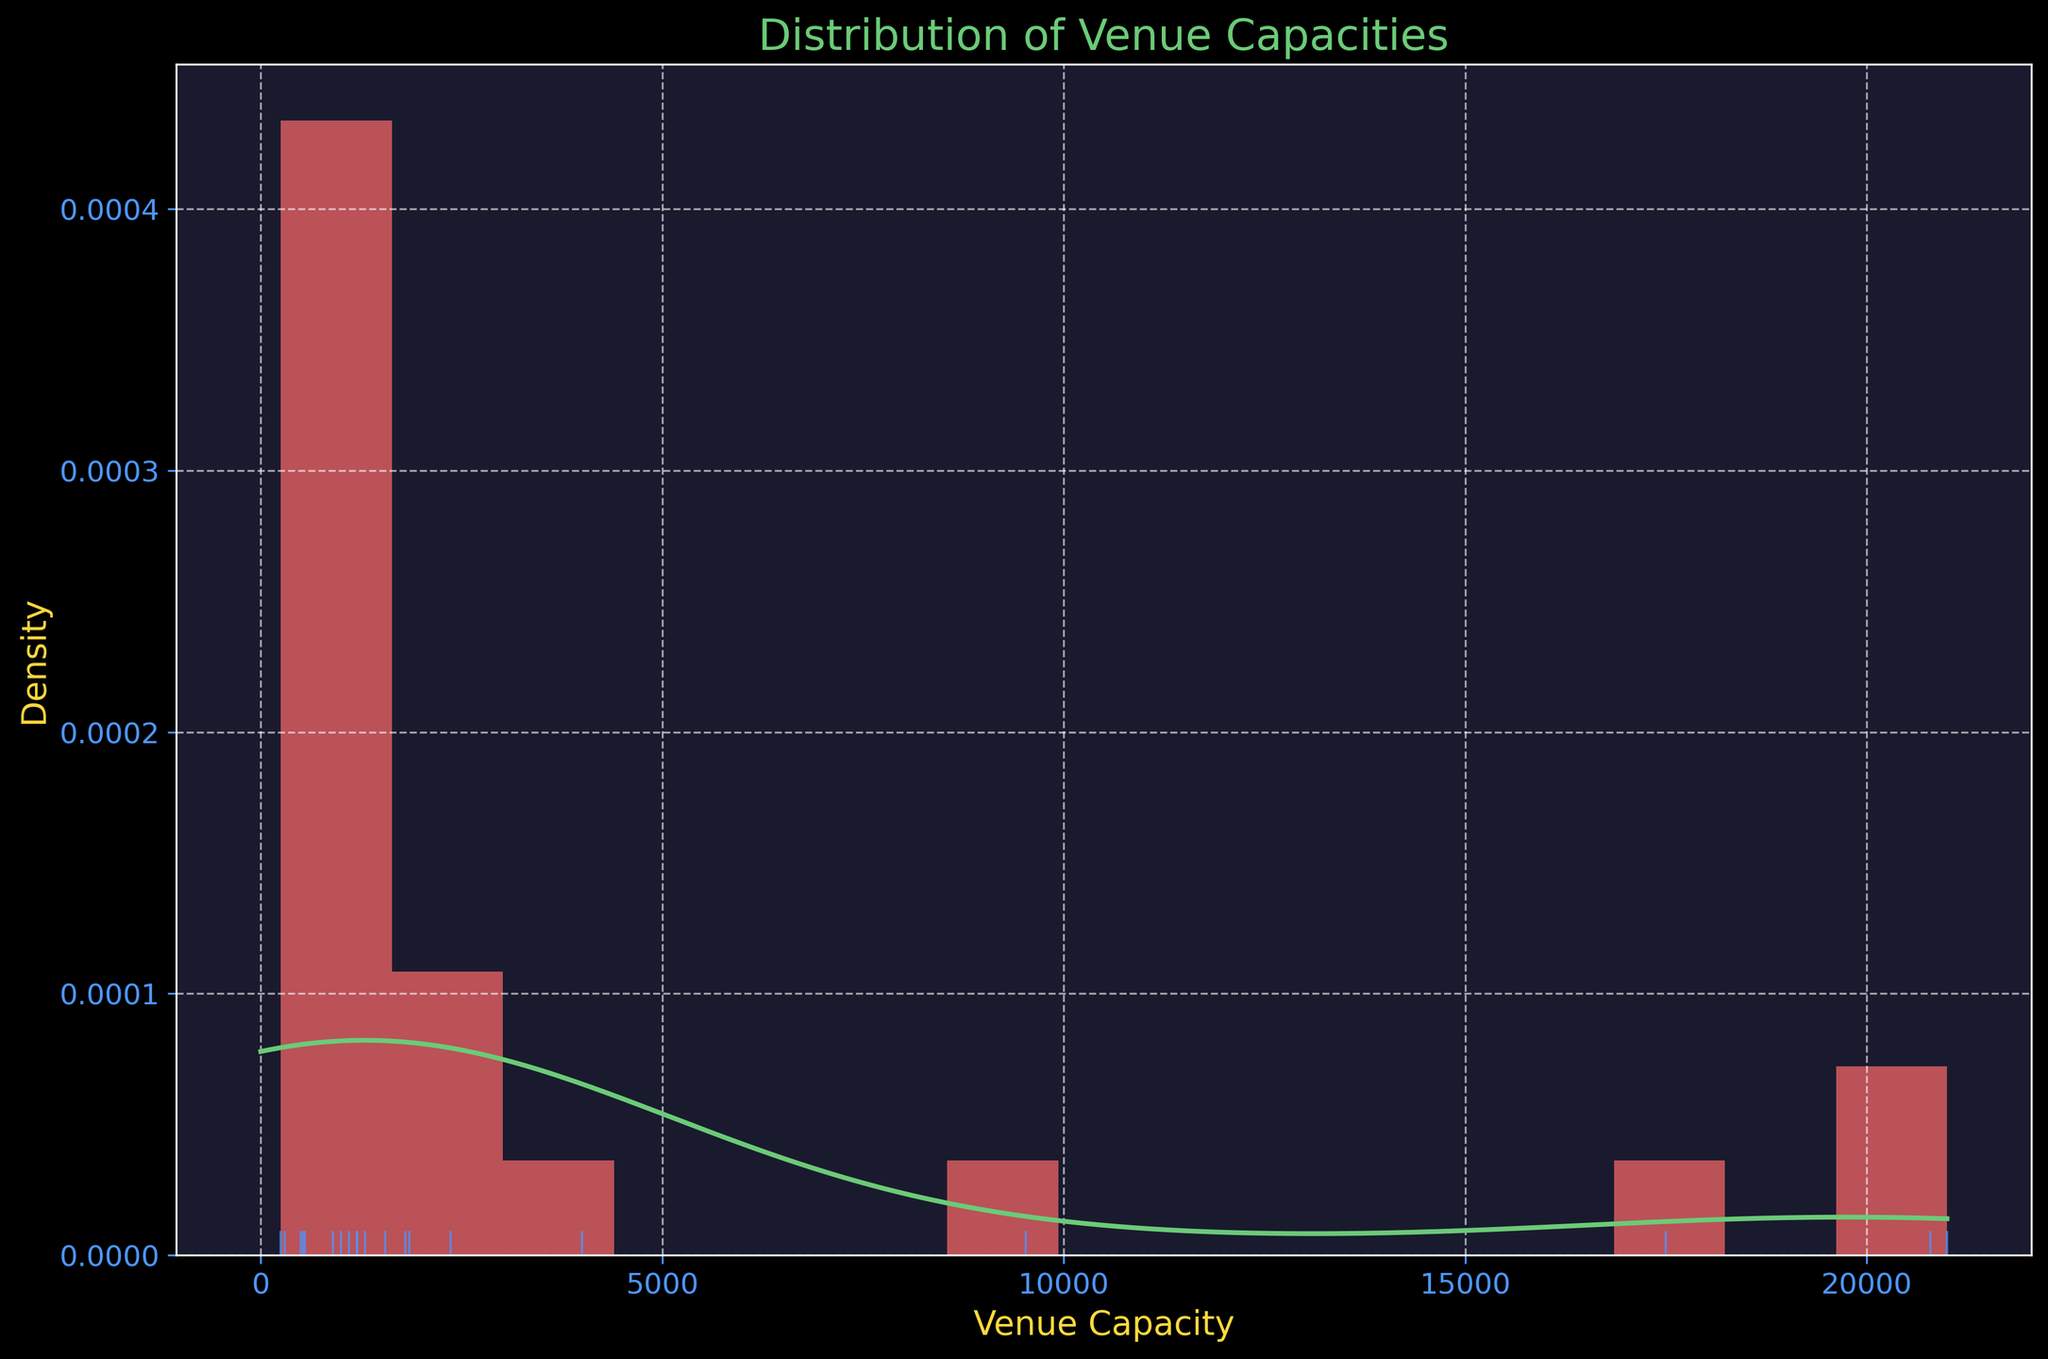What's the title of the plot? The title is usually found at the top of the plot. It describes what the plot is showing.
Answer: Distribution of Venue Capacities What is the x-axis label? The label for the x-axis indicates what is being measured on that axis.
Answer: Venue Capacity How many data points are shown in the rug plot? The rug plot shows individual values as tick marks along the x-axis. Count each tick mark to determine the number of data points.
Answer: 19 What is the general shape of the distribution? By observing the histogram and the KDE (kernel density estimate) line, you can determine the shape of the distribution (normal, skewed, etc.).
Answer: Right-skewed What is the range of the capacity values shown in the plot? The range is the difference between the maximum and minimum venue capacities shown on the x-axis. Identify the minimum and maximum values by inspecting the axis range.
Answer: 250 to 21,000 Which venue capacity range appears to have the highest density? The height of the histogram bars and the KDE line indicate the density. The highest density is where the tallest bars and the peak of the KDE line are located.
Answer: 0 to 1,000 What is the approximate value of the highest peak in the KDE line? Locate the highest point of the KDE line and read the approximate density value from the y-axis.
Answer: ~0.0002 Is the density higher for venues with capacities less than 1,000 or more than 10,000? Compare the overall height of the histogram bars and KDE line for the two specified capacity ranges.
Answer: Less than 1,000 How many venue capacities fall below 5,000? Count the number of tick marks (data points) in the rug plot that are positioned below the 5,000 mark on the x-axis.
Answer: 14 What is the color of the histogram bars? The color of the histogram bars can be seen directly from the plot, where the bars are drawn.
Answer: Red 